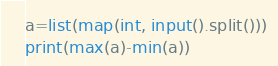<code> <loc_0><loc_0><loc_500><loc_500><_Python_>a=list(map(int, input().split()))
print(max(a)-min(a))</code> 